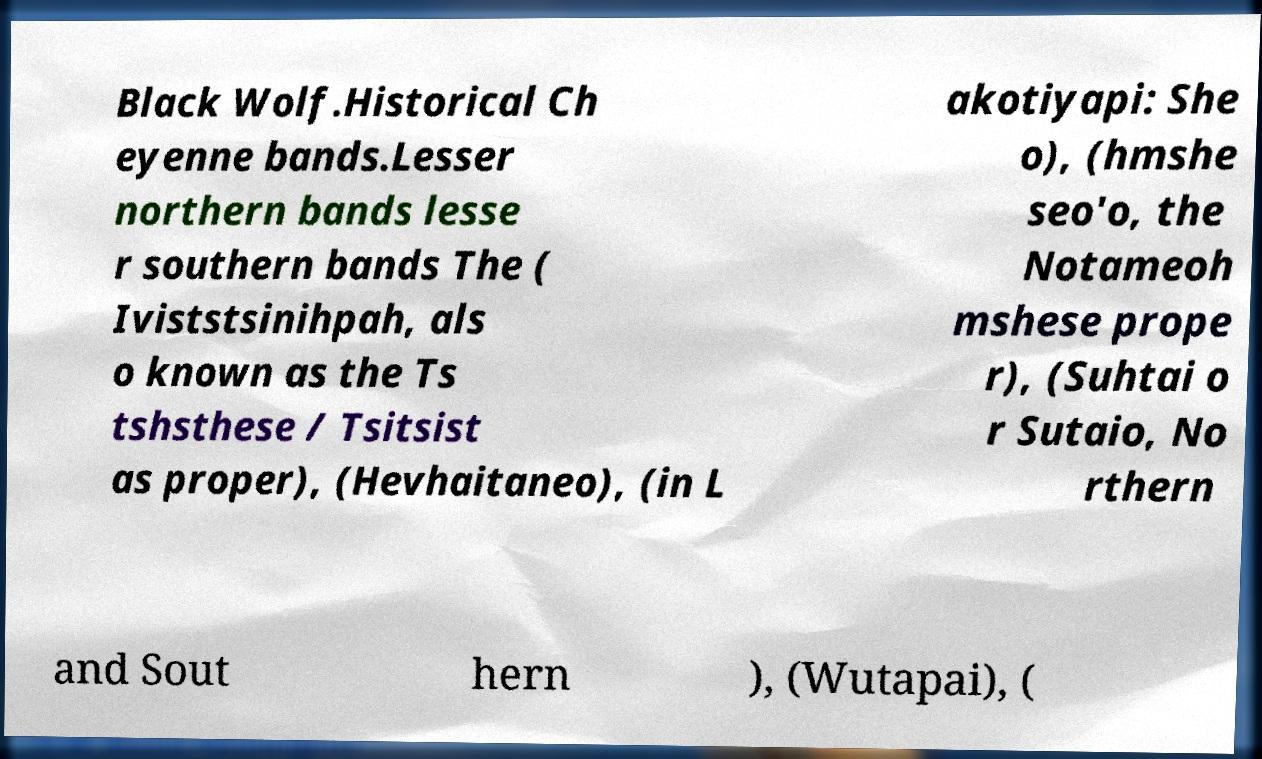There's text embedded in this image that I need extracted. Can you transcribe it verbatim? Black Wolf.Historical Ch eyenne bands.Lesser northern bands lesse r southern bands The ( Iviststsinihpah, als o known as the Ts tshsthese / Tsitsist as proper), (Hevhaitaneo), (in L akotiyapi: She o), (hmshe seo'o, the Notameoh mshese prope r), (Suhtai o r Sutaio, No rthern and Sout hern ), (Wutapai), ( 